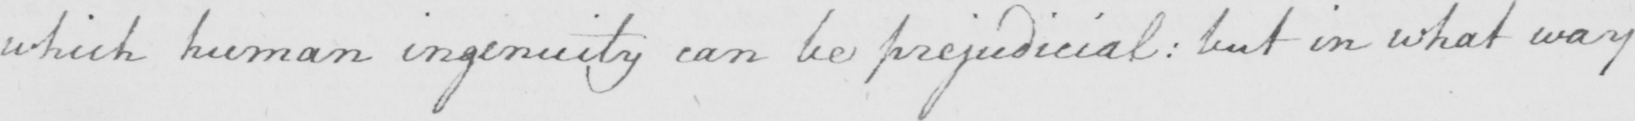Please transcribe the handwritten text in this image. which human ingenuity can be prejudicial :  but in what way 